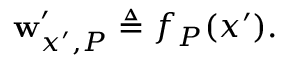Convert formula to latex. <formula><loc_0><loc_0><loc_500><loc_500>w _ { x ^ { \prime } , P } ^ { \prime } \triangle q f _ { P } ( x ^ { \prime } ) .</formula> 